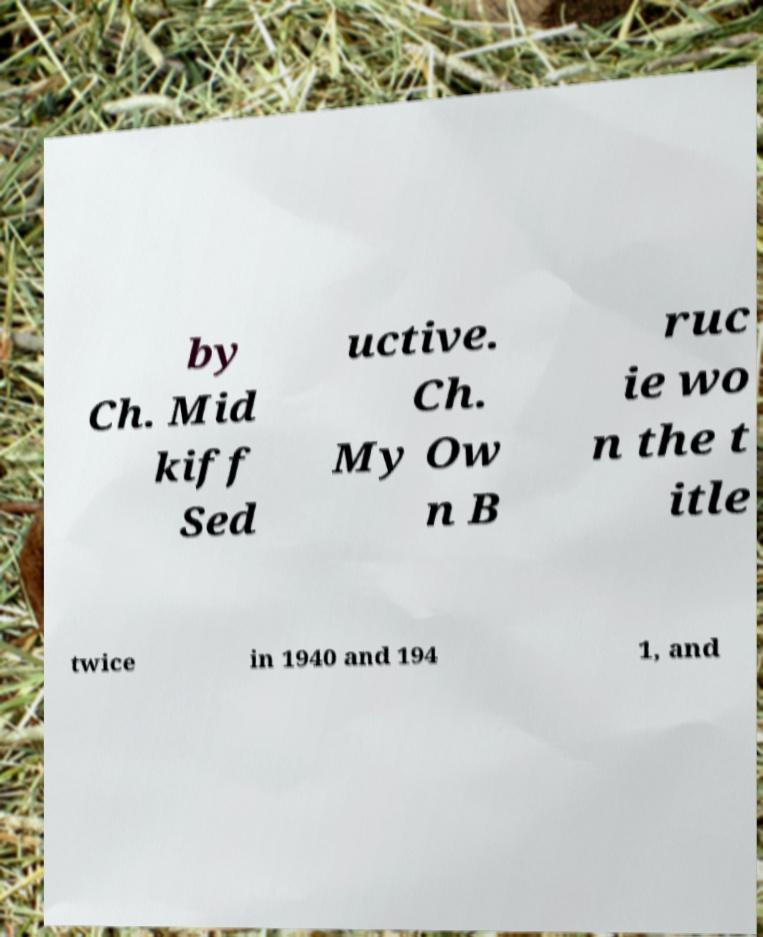Could you extract and type out the text from this image? by Ch. Mid kiff Sed uctive. Ch. My Ow n B ruc ie wo n the t itle twice in 1940 and 194 1, and 